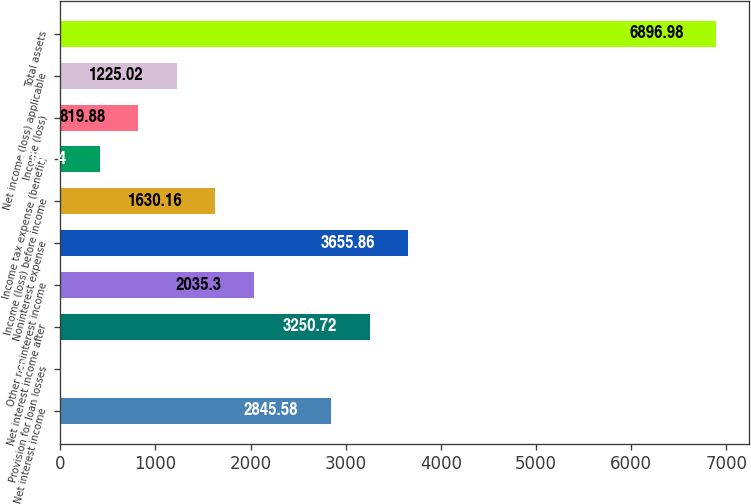Convert chart. <chart><loc_0><loc_0><loc_500><loc_500><bar_chart><fcel>Net interest income<fcel>Provision for loan losses<fcel>Net interest income after<fcel>Other noninterest income<fcel>Noninterest expense<fcel>Income (loss) before income<fcel>Income tax expense (benefit)<fcel>Income (loss)<fcel>Net income (loss) applicable<fcel>Total assets<nl><fcel>2845.58<fcel>9.6<fcel>3250.72<fcel>2035.3<fcel>3655.86<fcel>1630.16<fcel>414.74<fcel>819.88<fcel>1225.02<fcel>6896.98<nl></chart> 